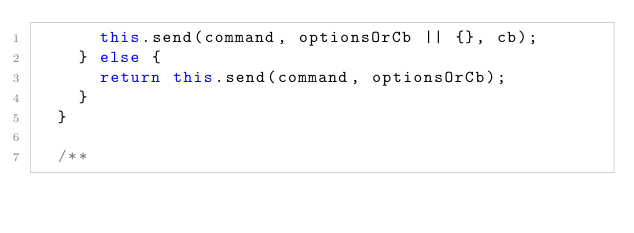Convert code to text. <code><loc_0><loc_0><loc_500><loc_500><_TypeScript_>      this.send(command, optionsOrCb || {}, cb);
    } else {
      return this.send(command, optionsOrCb);
    }
  }

  /**</code> 